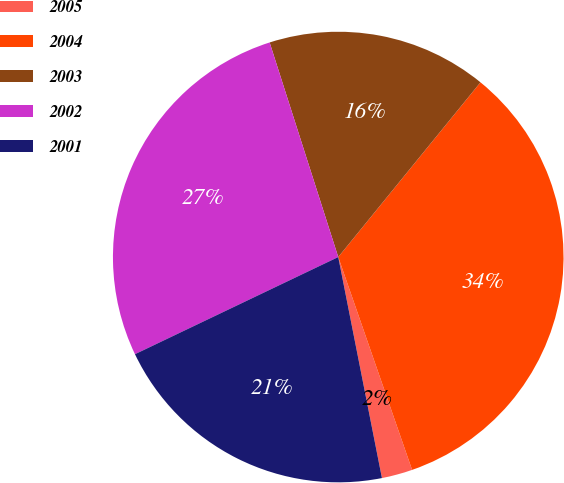<chart> <loc_0><loc_0><loc_500><loc_500><pie_chart><fcel>2005<fcel>2004<fcel>2003<fcel>2002<fcel>2001<nl><fcel>2.21%<fcel>33.81%<fcel>15.8%<fcel>27.17%<fcel>21.01%<nl></chart> 